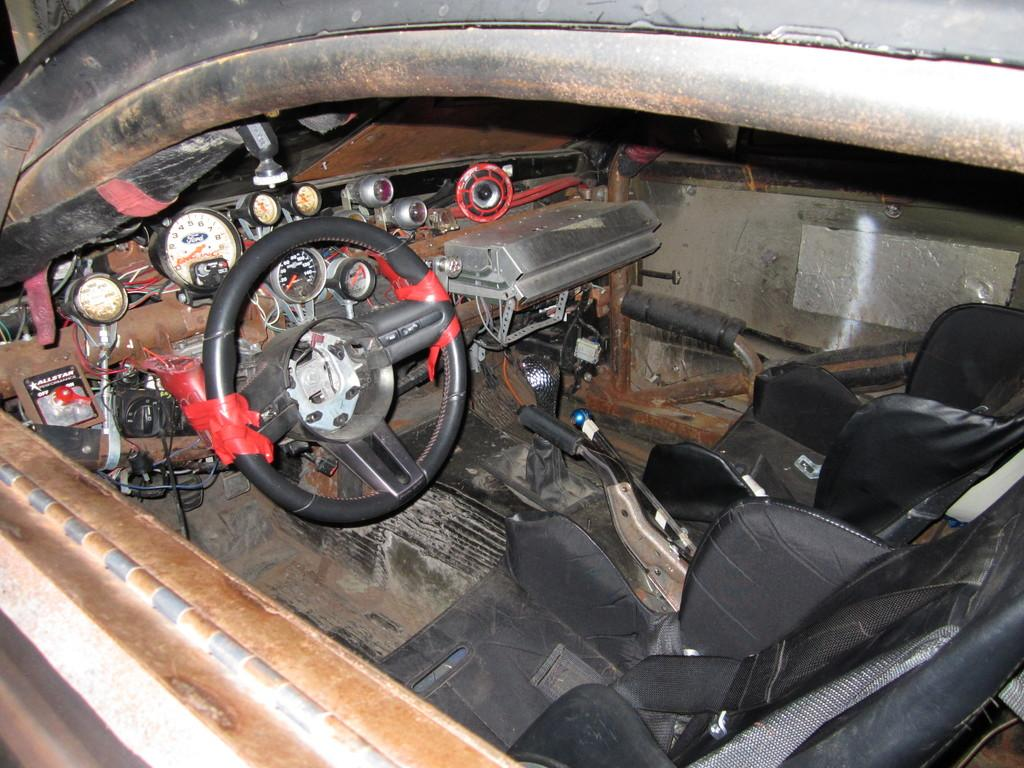What type of vehicle is depicted in the image? The image appears to be of a car. What is one of the main components of a car that is visible in the image? There is a steering wheel in the car. What instrument is used to measure the car's performance that is visible in the image? There is an auto gauge in the car. How many seats are visible in the car in the image? There are seats in the car. What mechanism is used to change gears in the car that is visible in the image? There is a gear in the car. What safety feature is visible in the car that is used to prevent rolling when parked? There is a hand brake in the car. What other objects are attached to the car that are visible in the image? There are other objects attached to the car. How many boats are visible in the image? There are no boats visible in the image; it is a car. What type of butter is being used to grease the bucket in the image? There is no bucket or butter present in the image. 